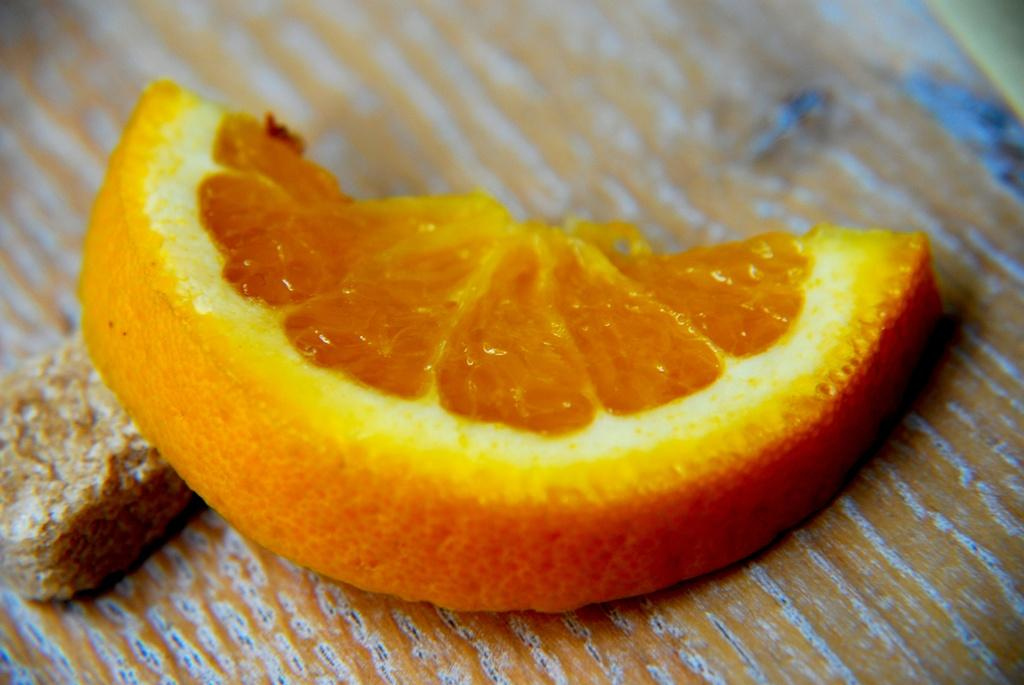What type of fruit is visible in the image? There is a slice of orange in the image. What is the slice of orange placed on? The slice of orange is placed on a yellow sheet. Can you describe the edible item in the image? The edible item in the image is a slice of orange. How would you describe the background of the image? The background of the image is blurred. What type of lamp is present in the image? There is no lamp present in the image. Can you describe the chair in the image? There is no chair present in the image. 